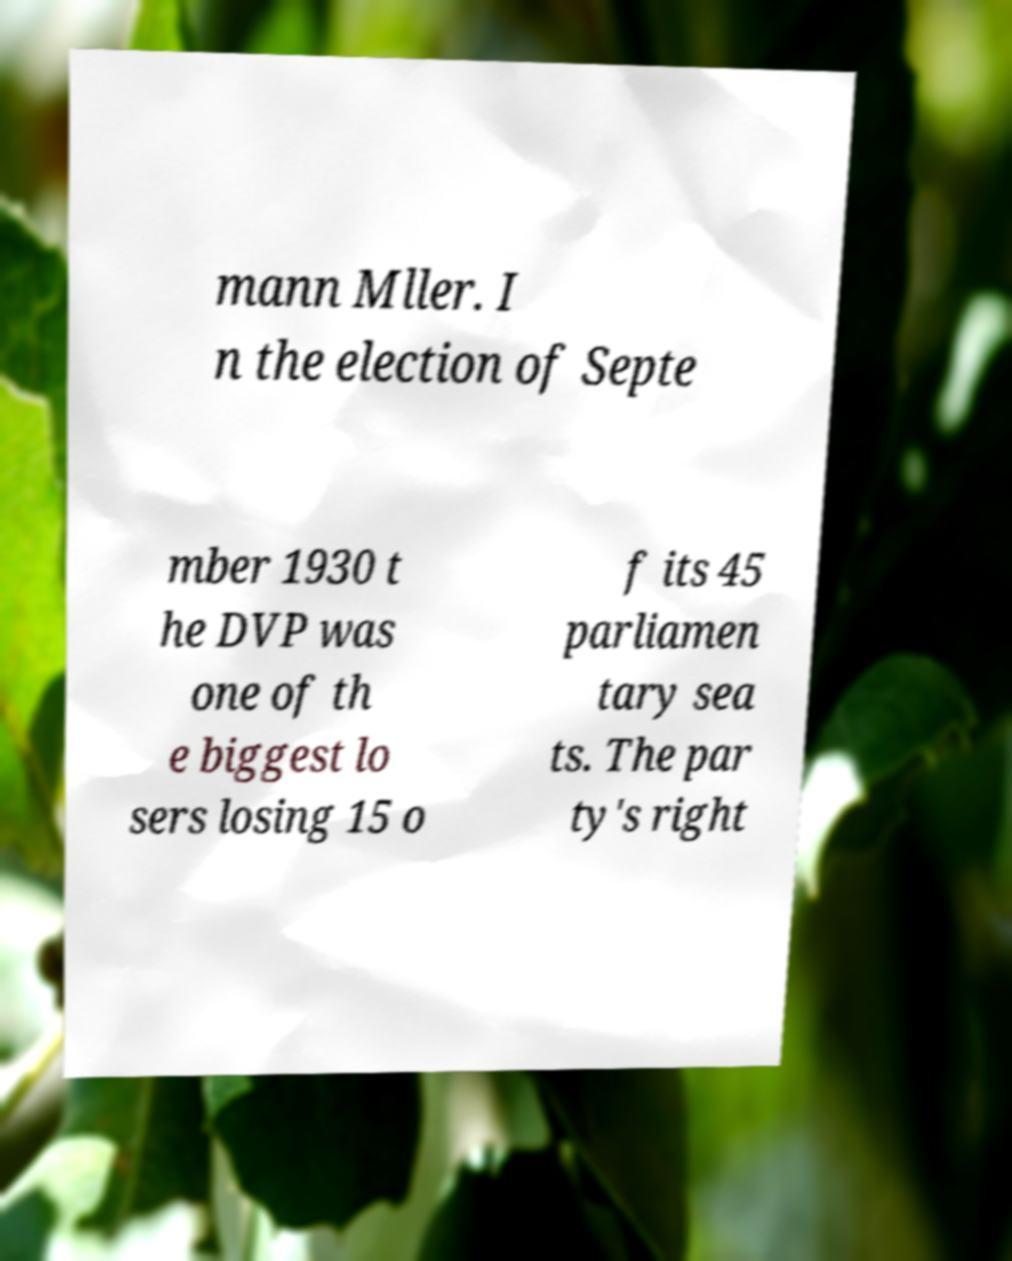Could you extract and type out the text from this image? mann Mller. I n the election of Septe mber 1930 t he DVP was one of th e biggest lo sers losing 15 o f its 45 parliamen tary sea ts. The par ty's right 